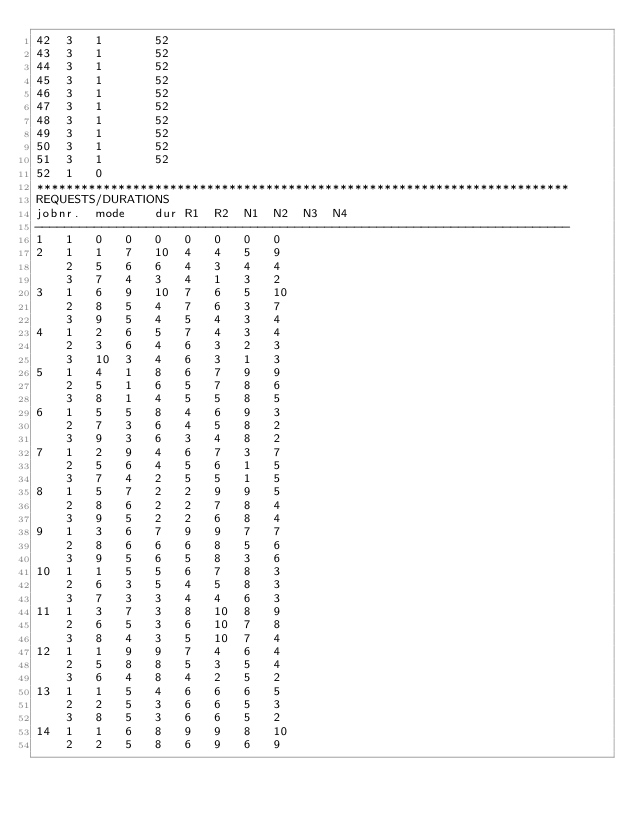Convert code to text. <code><loc_0><loc_0><loc_500><loc_500><_ObjectiveC_>42	3	1		52 
43	3	1		52 
44	3	1		52 
45	3	1		52 
46	3	1		52 
47	3	1		52 
48	3	1		52 
49	3	1		52 
50	3	1		52 
51	3	1		52 
52	1	0		
************************************************************************
REQUESTS/DURATIONS
jobnr.	mode	dur	R1	R2	N1	N2	N3	N4	
------------------------------------------------------------------------
1	1	0	0	0	0	0	0	0	
2	1	1	7	10	4	4	5	9	
	2	5	6	6	4	3	4	4	
	3	7	4	3	4	1	3	2	
3	1	6	9	10	7	6	5	10	
	2	8	5	4	7	6	3	7	
	3	9	5	4	5	4	3	4	
4	1	2	6	5	7	4	3	4	
	2	3	6	4	6	3	2	3	
	3	10	3	4	6	3	1	3	
5	1	4	1	8	6	7	9	9	
	2	5	1	6	5	7	8	6	
	3	8	1	4	5	5	8	5	
6	1	5	5	8	4	6	9	3	
	2	7	3	6	4	5	8	2	
	3	9	3	6	3	4	8	2	
7	1	2	9	4	6	7	3	7	
	2	5	6	4	5	6	1	5	
	3	7	4	2	5	5	1	5	
8	1	5	7	2	2	9	9	5	
	2	8	6	2	2	7	8	4	
	3	9	5	2	2	6	8	4	
9	1	3	6	7	9	9	7	7	
	2	8	6	6	6	8	5	6	
	3	9	5	6	5	8	3	6	
10	1	1	5	5	6	7	8	3	
	2	6	3	5	4	5	8	3	
	3	7	3	3	4	4	6	3	
11	1	3	7	3	8	10	8	9	
	2	6	5	3	6	10	7	8	
	3	8	4	3	5	10	7	4	
12	1	1	9	9	7	4	6	4	
	2	5	8	8	5	3	5	4	
	3	6	4	8	4	2	5	2	
13	1	1	5	4	6	6	6	5	
	2	2	5	3	6	6	5	3	
	3	8	5	3	6	6	5	2	
14	1	1	6	8	9	9	8	10	
	2	2	5	8	6	9	6	9	</code> 